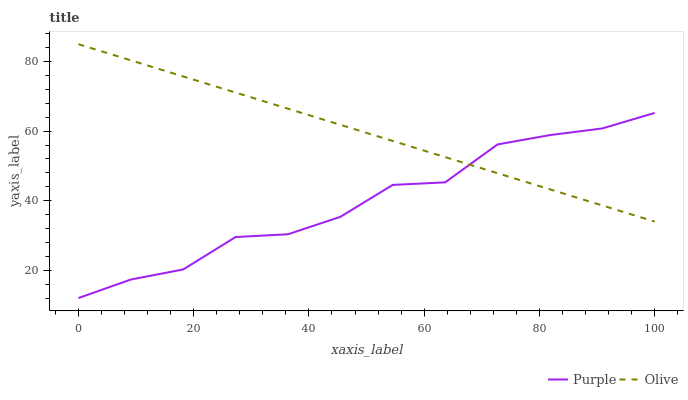Does Olive have the minimum area under the curve?
Answer yes or no. No. Is Olive the roughest?
Answer yes or no. No. Does Olive have the lowest value?
Answer yes or no. No. 